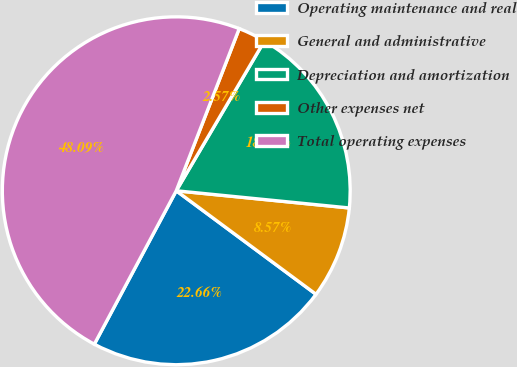Convert chart. <chart><loc_0><loc_0><loc_500><loc_500><pie_chart><fcel>Operating maintenance and real<fcel>General and administrative<fcel>Depreciation and amortization<fcel>Other expenses net<fcel>Total operating expenses<nl><fcel>22.66%<fcel>8.57%<fcel>18.11%<fcel>2.57%<fcel>48.09%<nl></chart> 